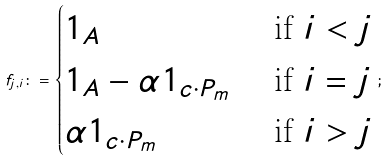Convert formula to latex. <formula><loc_0><loc_0><loc_500><loc_500>f _ { j , i } \colon = \begin{cases} 1 _ { A } & \text { if } i < j \\ 1 _ { A } - \alpha 1 _ { c \cdot P _ { m } } & \text { if } i = j \\ \alpha 1 _ { c \cdot P _ { m } } & \text { if } i > j \end{cases} ;</formula> 